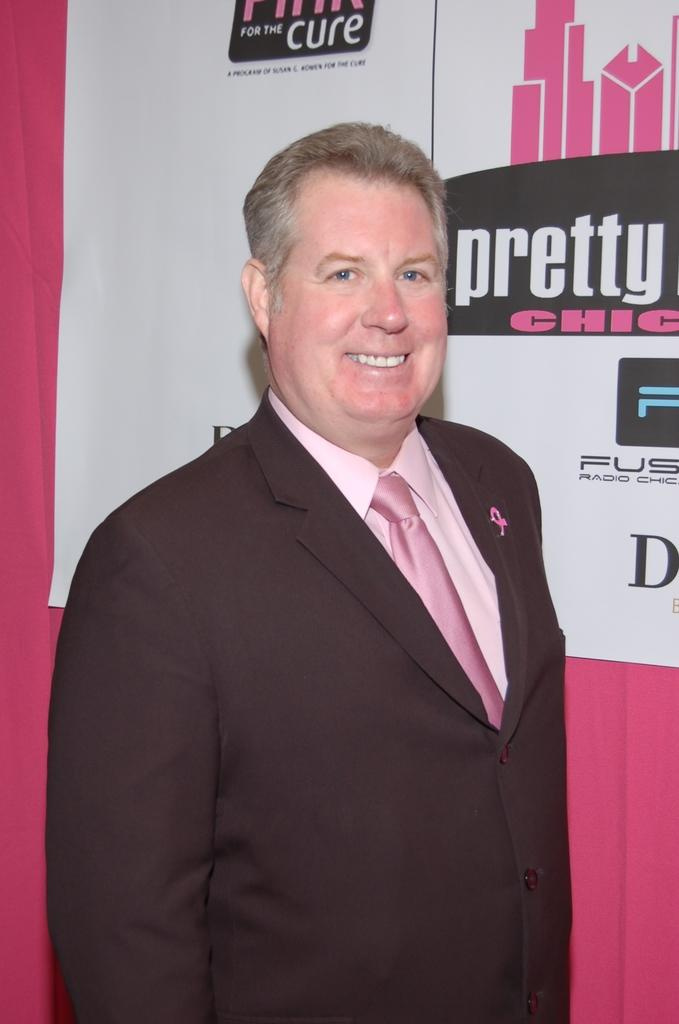Provide a one-sentence caption for the provided image. A man poses for a photo in front of a pink and white background that says pretty chic and for the cure. 